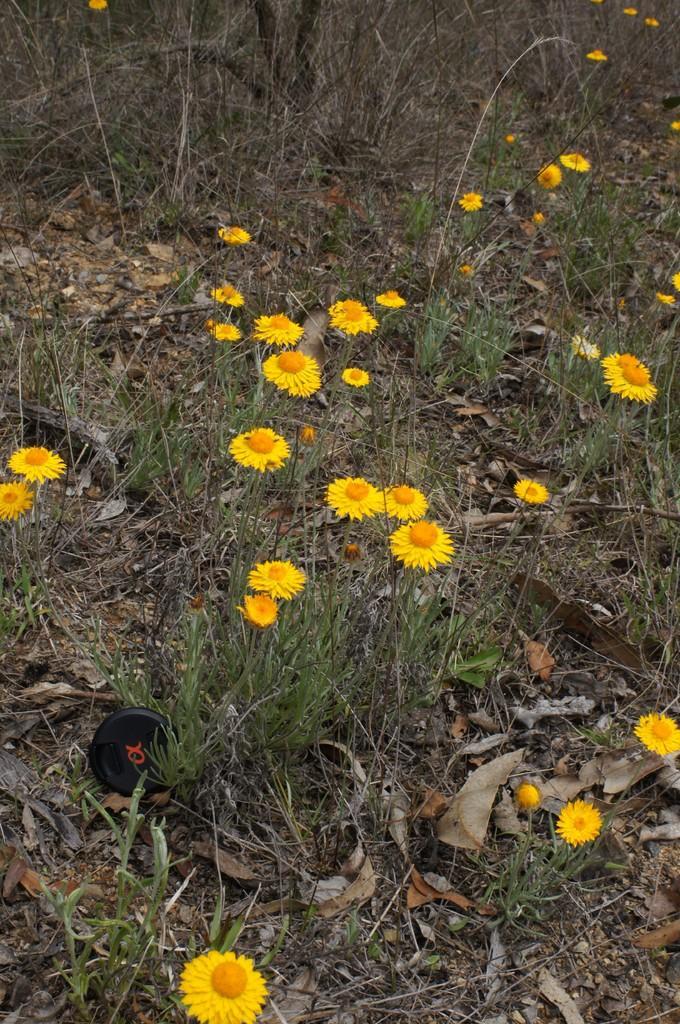In one or two sentences, can you explain what this image depicts? This image is taken outdoors. At the bottom of the image there is a ground with grass and dry leaves on it and there are a few flowers which are yellow in color. 